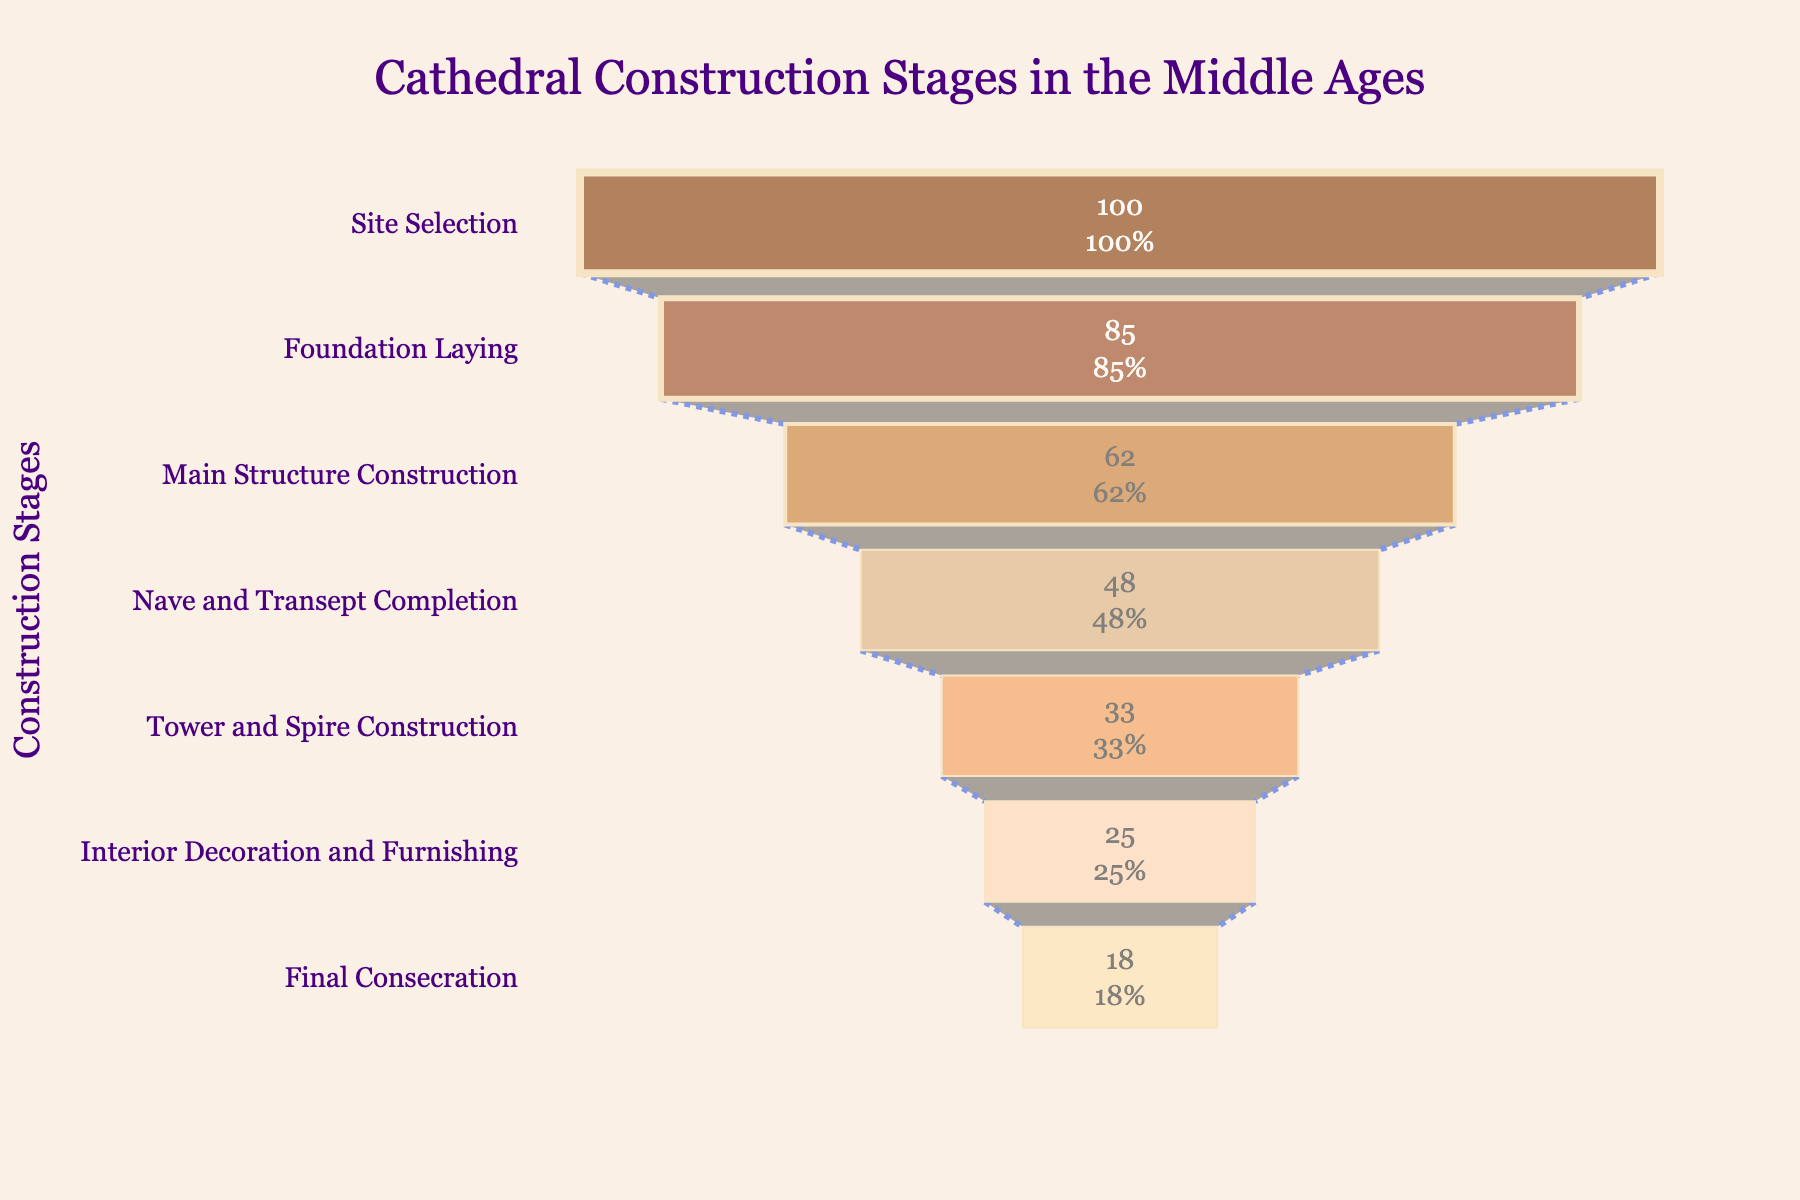What is the title of the funnel chart? The title is displayed prominently at the top of the funnel chart. It reads, "Cathedral Construction Stages in the Middle Ages."
Answer: Cathedral Construction Stages in the Middle Ages What is the completion rate for the 'Tower and Spire Construction' stage? Look at the corresponding funnel section for 'Tower and Spire Construction.' The completion rate for this stage is clearly labeled inside the section.
Answer: 33% By how much does the completion rate decrease from 'Foundation Laying' to 'Main Structure Construction'? Compare the completion rates of 'Foundation Laying' and 'Main Structure Construction.' The decrease can be calculated by subtracting the latter from the former (85% - 62%).
Answer: 23% What is the difference in completion rates between the 'Nave and Transept Completion' and 'Final Consecration' stages? Compare these two stages by subtracting the completion rate of 'Final Consecration' from 'Nave and Transept Completion' (48% - 18%).
Answer: 30% Which stage has the highest completion rate and what is it? The funnel chart starts with the stage that has the highest completion rate. The top-most section in the chart is 'Site Selection.' It shows a completion rate of 100%.
Answer: Site Selection, 100% What is the average completion rate for the stages shown in the funnel chart? To find the average completion rate, sum all completion rates and divide by the number of stages (100% + 85% + 62% + 48% + 33% + 25% + 18%) / 7.
Answer: 52.43% Which stage marks the halfway point in terms of completion rate (approximately closest to 50%)? Examine the completion rates: 'Nave and Transept Completion' is 48%, which is closest to 50%.
Answer: Nave and Transept Completion How many stages have a completion rate greater than or equal to 50%? Identify and count the stages with completion rates of 50% or higher: 'Site Selection,' 'Foundation Laying,' 'Main Structure Construction.'
Answer: 3 What color represents the 'Interior Decoration and Furnishing' stage? The color of each stage in the funnel is distinct. 'Interior Decoration and Furnishing' is specifically marked with a light shade.
Answer: Light Peach (approx. #FFDAB9) Which stage has the lowest completion rate and what is it? The chart ends with the stage that has the lowest completion rate. The bottom-most section in the chart is 'Final Consecration.' It shows a completion rate of 18%.
Answer: Final Consecration, 18% 